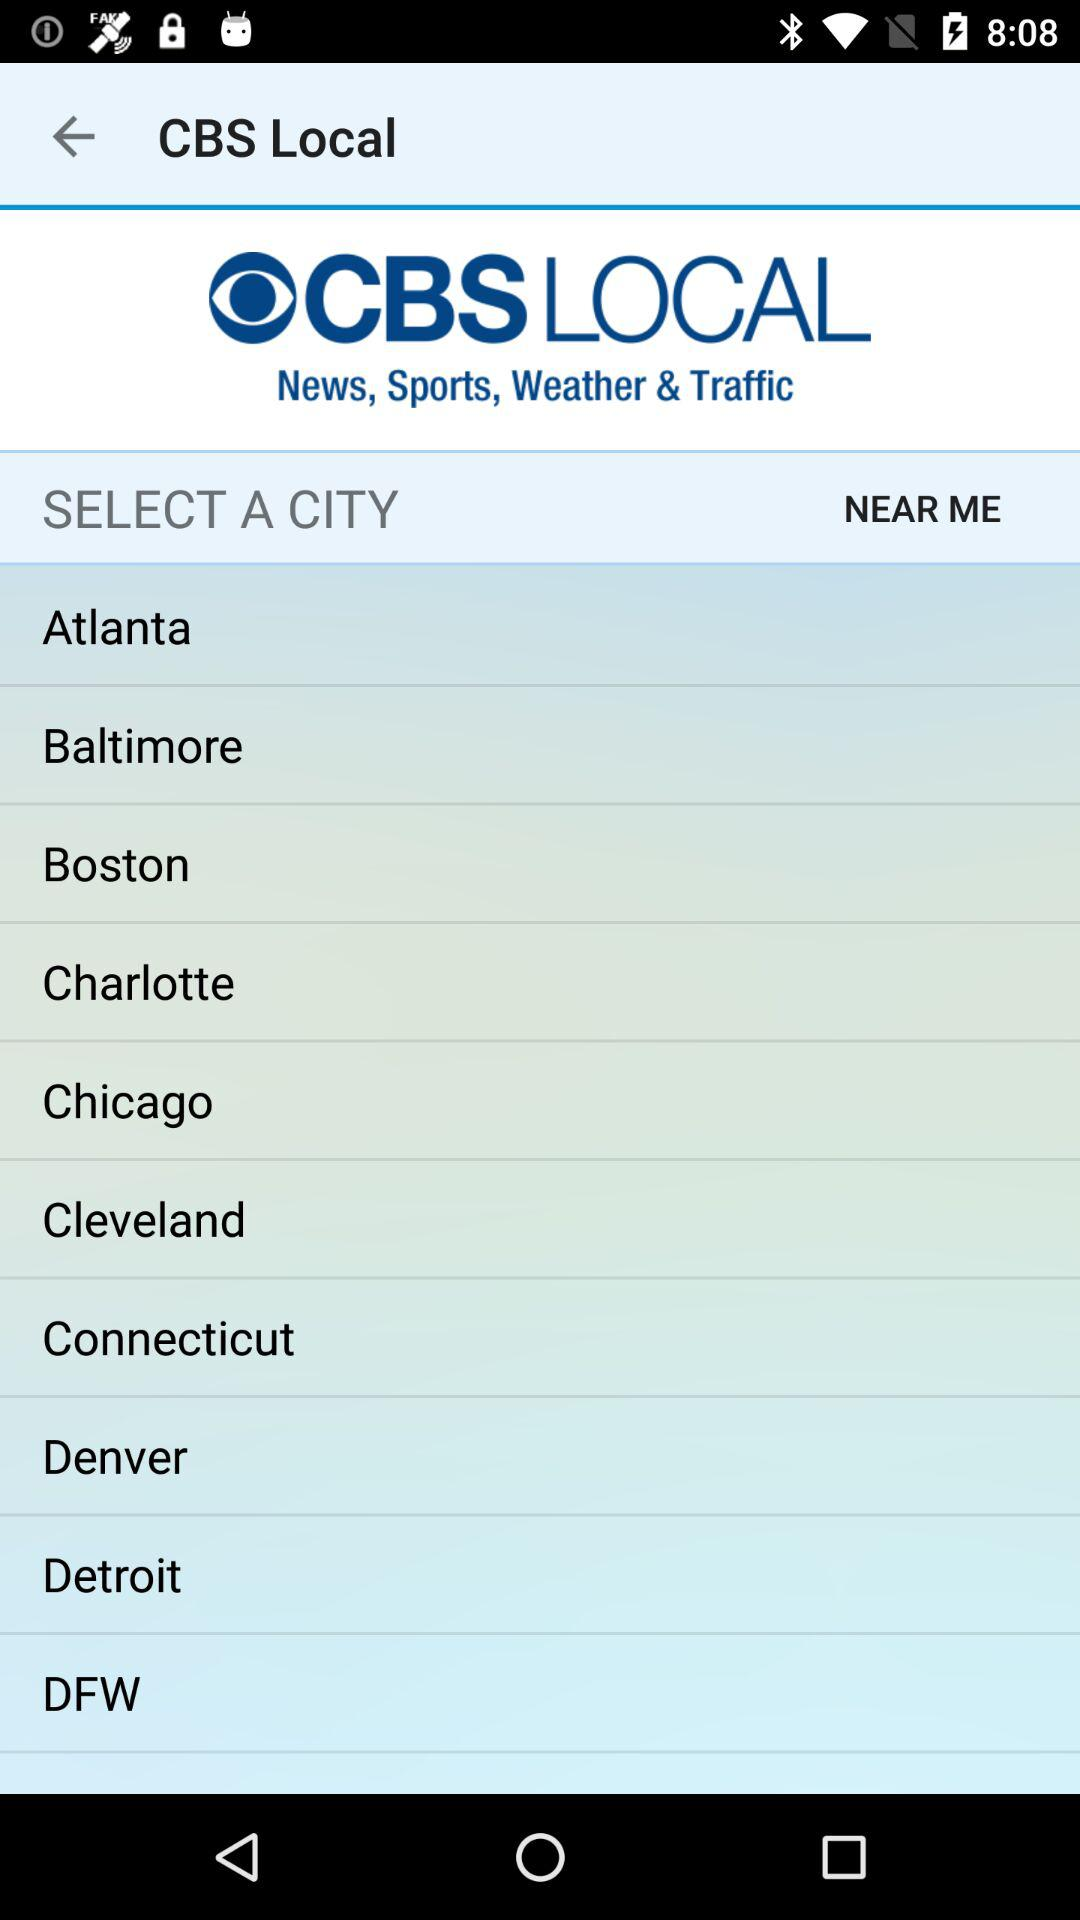What is the name of the application? The name of the application is "CBS Local". 